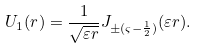Convert formula to latex. <formula><loc_0><loc_0><loc_500><loc_500>U _ { 1 } ( r ) = \frac { 1 } { \sqrt { \varepsilon r } } J _ { \pm ( \varsigma - \frac { 1 } { 2 } ) } ( \varepsilon r ) .</formula> 